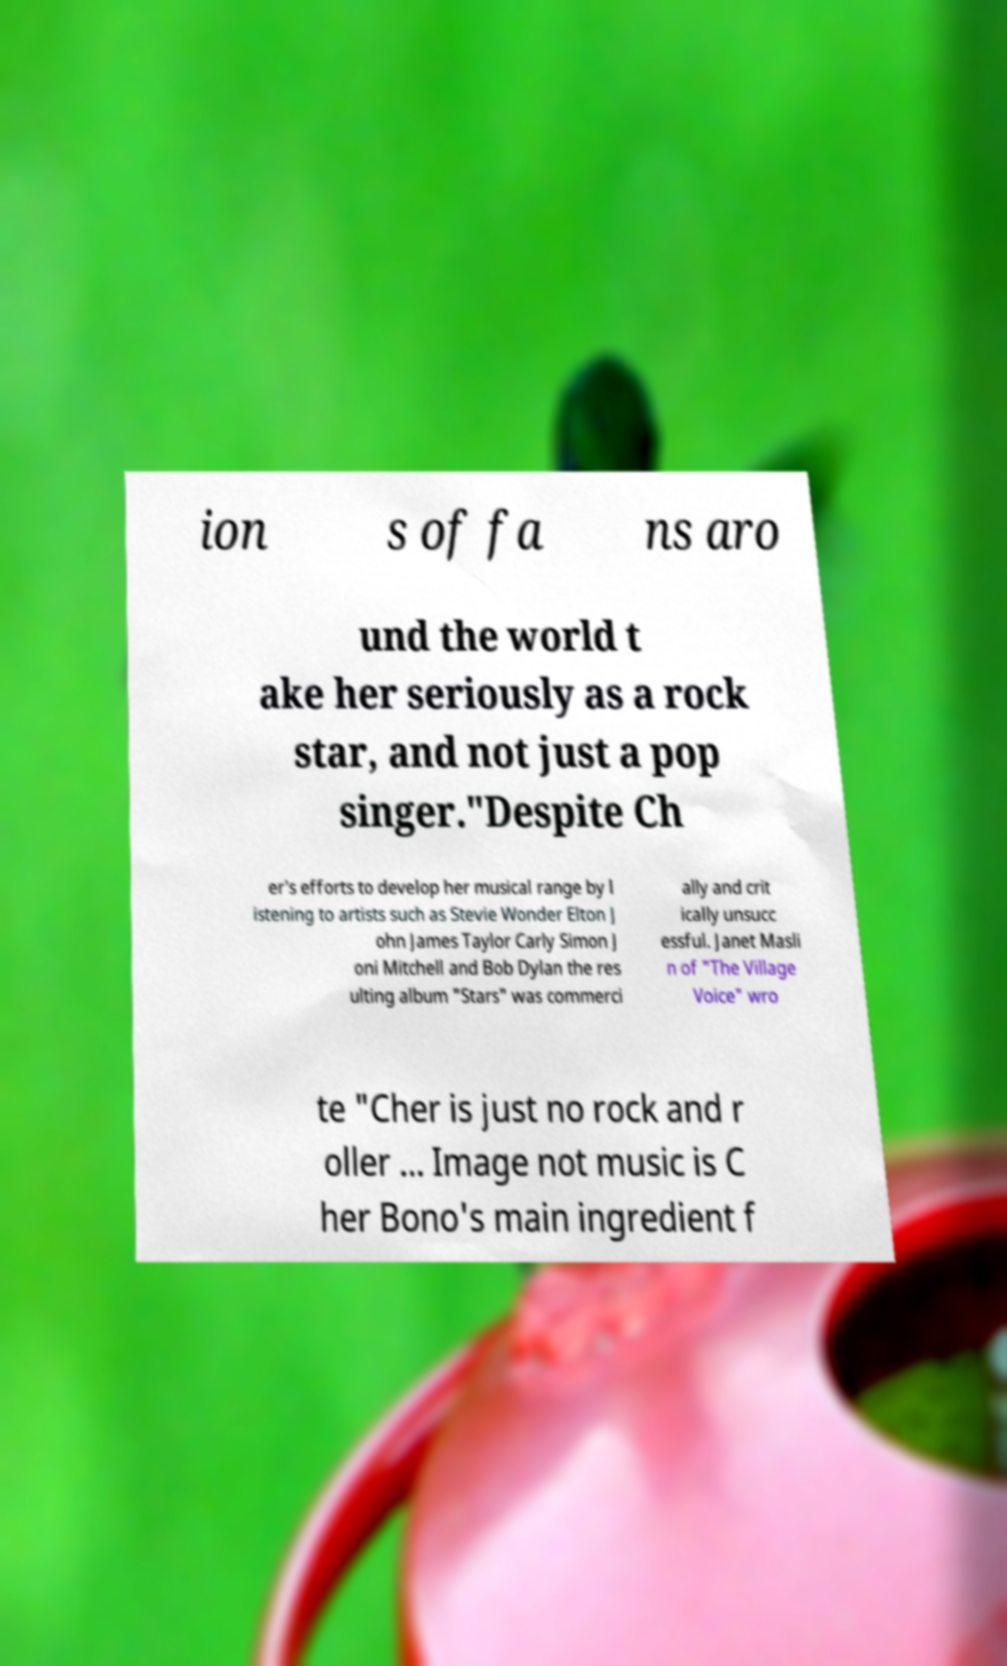What messages or text are displayed in this image? I need them in a readable, typed format. ion s of fa ns aro und the world t ake her seriously as a rock star, and not just a pop singer."Despite Ch er's efforts to develop her musical range by l istening to artists such as Stevie Wonder Elton J ohn James Taylor Carly Simon J oni Mitchell and Bob Dylan the res ulting album "Stars" was commerci ally and crit ically unsucc essful. Janet Masli n of "The Village Voice" wro te "Cher is just no rock and r oller ... Image not music is C her Bono's main ingredient f 